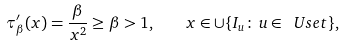Convert formula to latex. <formula><loc_0><loc_0><loc_500><loc_500>\tau ^ { \prime } _ { \beta } ( x ) = \frac { \beta } { x ^ { 2 } } \geq \beta > 1 , \quad x \in \cup \{ I _ { u } \colon \, u \in \ U s e t \} ,</formula> 